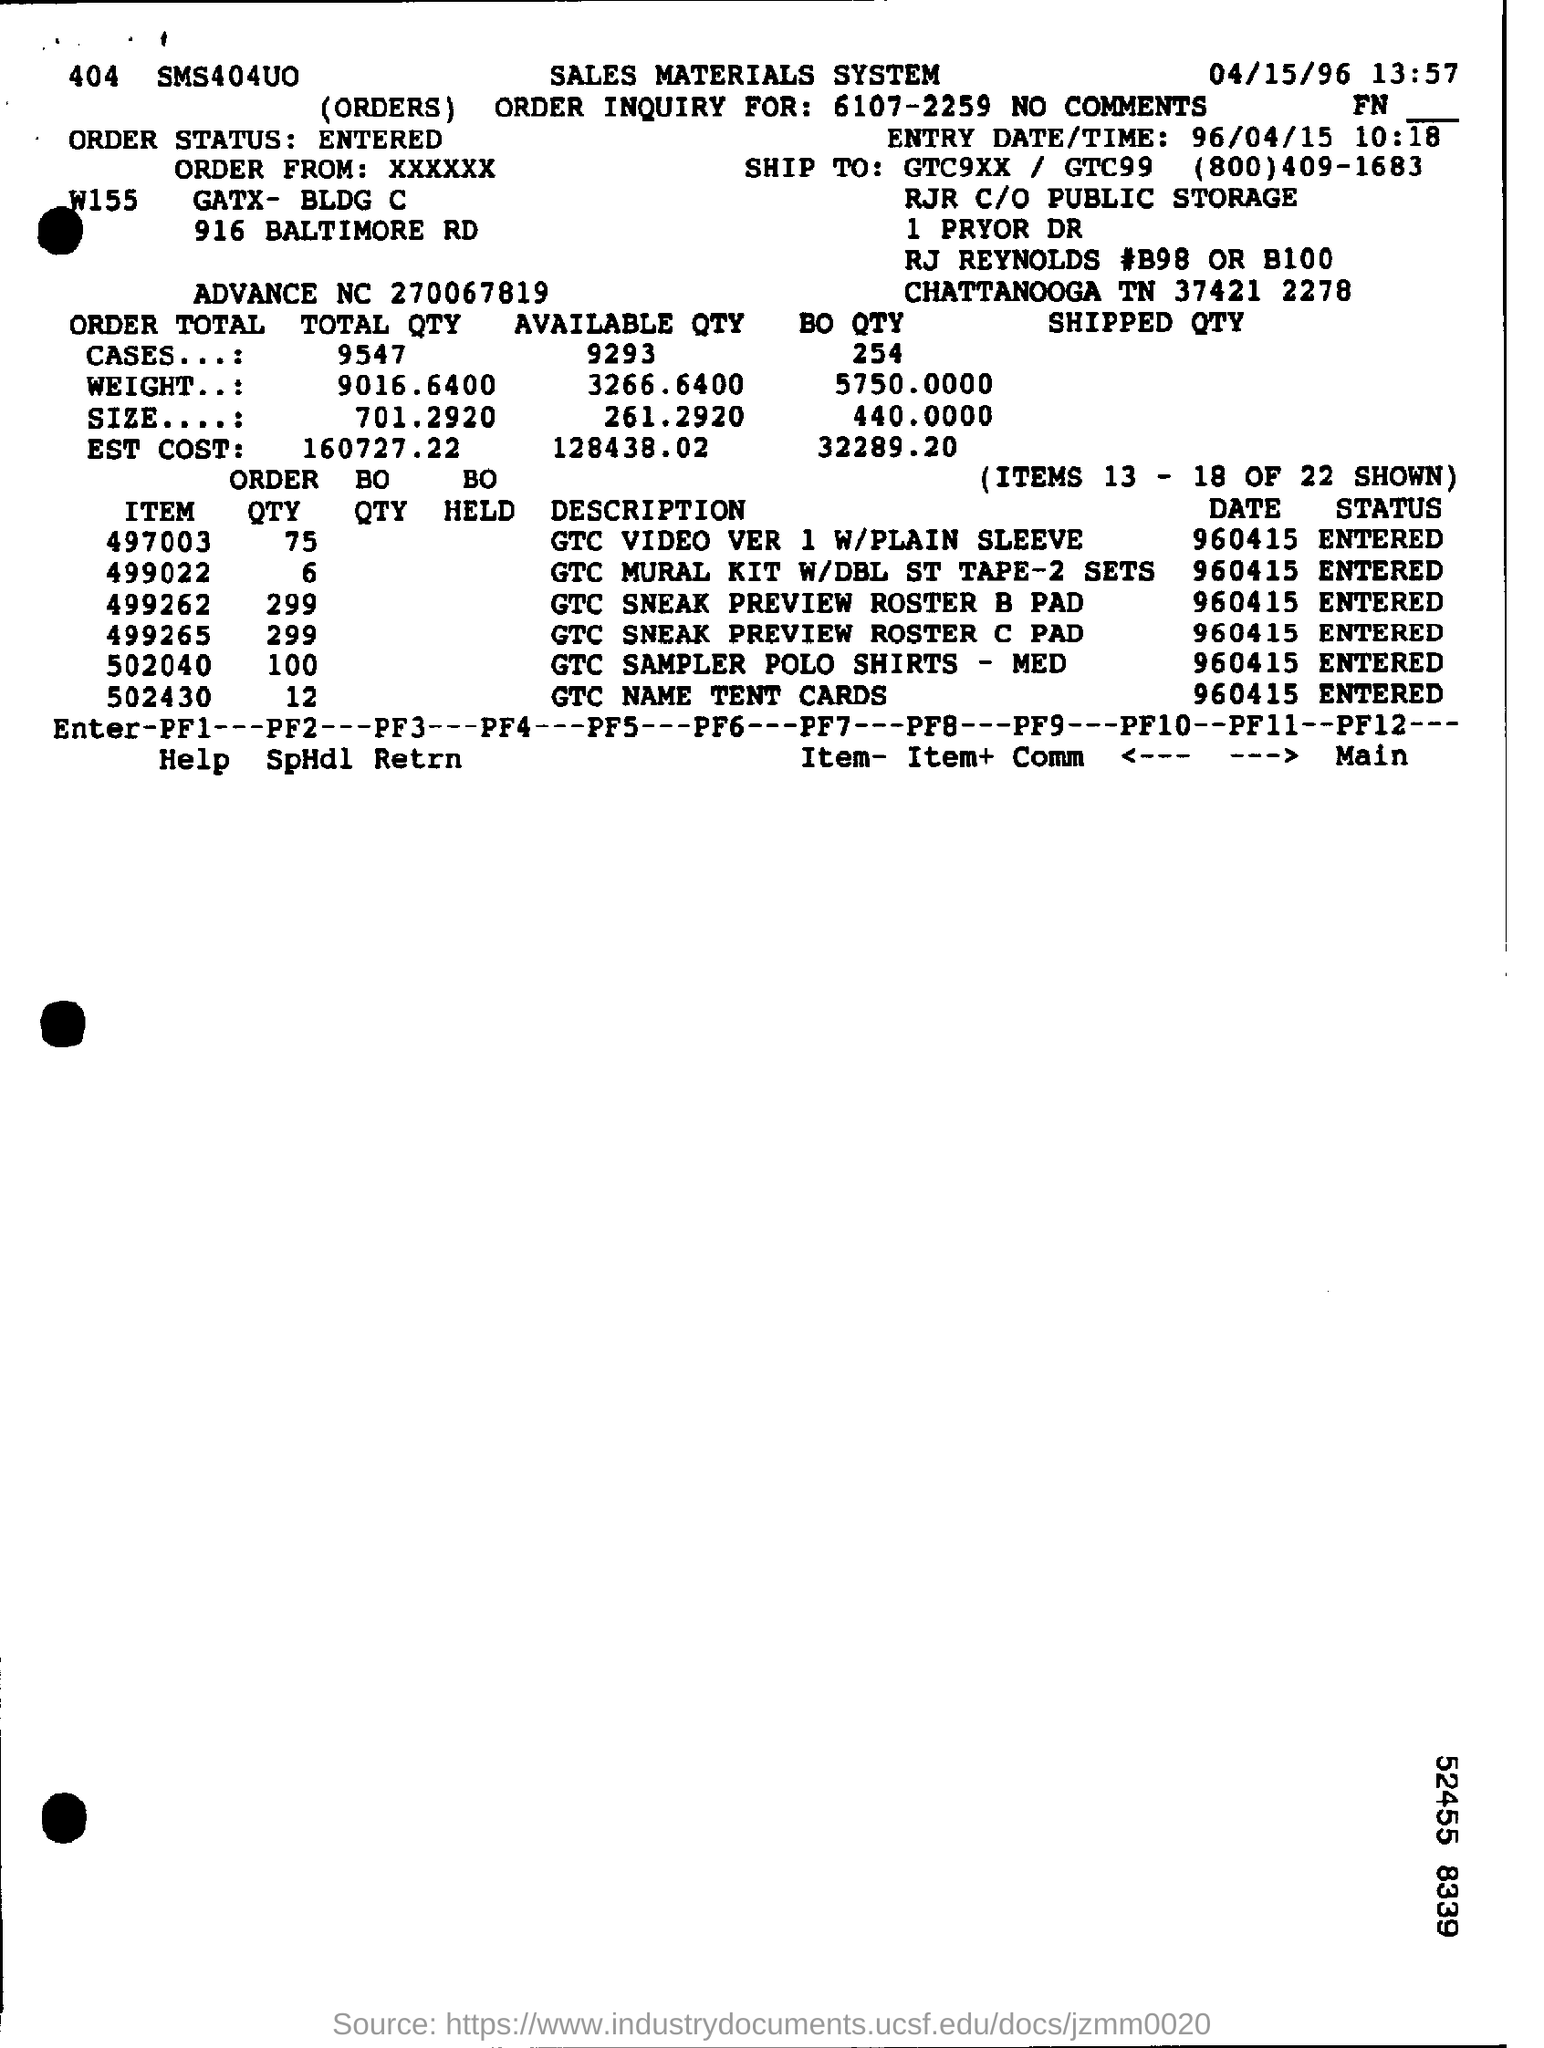What is the Order status?
Your answer should be compact. Entered. What is the total Qty for cases?
Offer a terse response. 9547. What is the weight for  the total Qty?
Give a very brief answer. 9016.6400. What is the size of the total qty?
Your answer should be very brief. 701.2920. What is the Est Cost for Total Qty?
Offer a terse response. 160727.22. What is the Available Qty for cases?
Offer a very short reply. 9293. What is the weight for the Available Qty?
Offer a terse response. 3266.6400. What is the size of the Available Qty?
Your answer should be very brief. 261.2920. What is the Est Cost for Available Qty?
Ensure brevity in your answer.  128438.02. What is the Entry date/Time?
Provide a short and direct response. 96/04/15 10:18. 